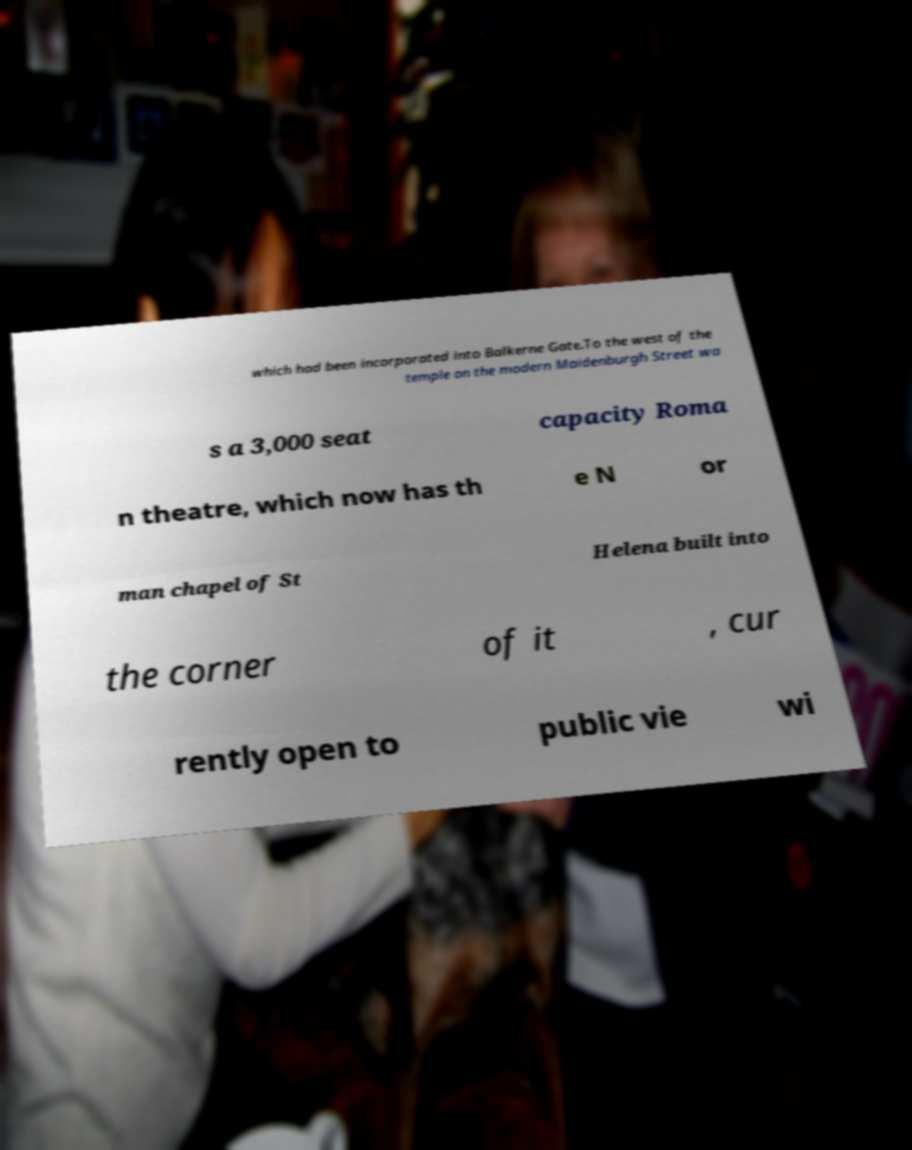Please identify and transcribe the text found in this image. which had been incorporated into Balkerne Gate.To the west of the temple on the modern Maidenburgh Street wa s a 3,000 seat capacity Roma n theatre, which now has th e N or man chapel of St Helena built into the corner of it , cur rently open to public vie wi 